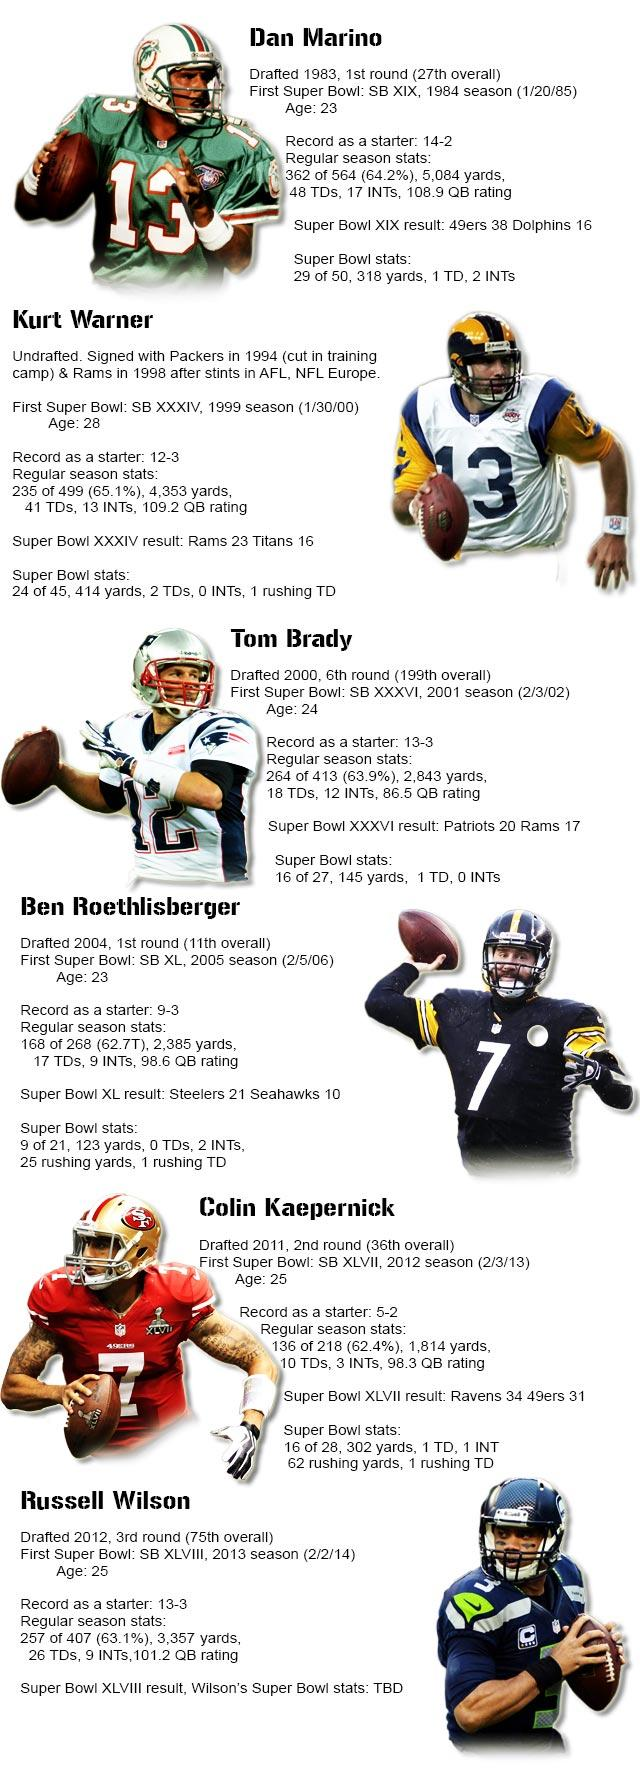Mention a couple of crucial points in this snapshot. In the season when the Ravens defeated the 49ers 34-31, Colin Kaepernick played his first Super Bowl match. Tom Brady made his first Super Bowl appearance in the 36th edition of the game. Dan Marino was 23 years old when he played in his first Super Bowl. The player Dan Marino played in the Dolphins versus 49ers Super Bowl match. Ben Roethlisberger played his first Super Bowl match on February 5th, 2006. 